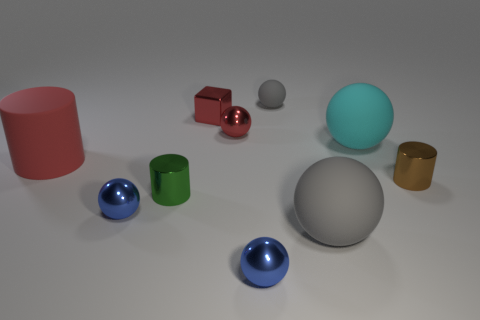Subtract 1 balls. How many balls are left? 5 Subtract all cyan spheres. How many spheres are left? 5 Subtract all tiny blue spheres. How many spheres are left? 4 Subtract all cyan spheres. Subtract all brown cylinders. How many spheres are left? 5 Subtract all cylinders. How many objects are left? 7 Subtract 0 purple cylinders. How many objects are left? 10 Subtract all tiny gray spheres. Subtract all tiny blue balls. How many objects are left? 7 Add 5 small red blocks. How many small red blocks are left? 6 Add 5 tiny green metal cylinders. How many tiny green metal cylinders exist? 6 